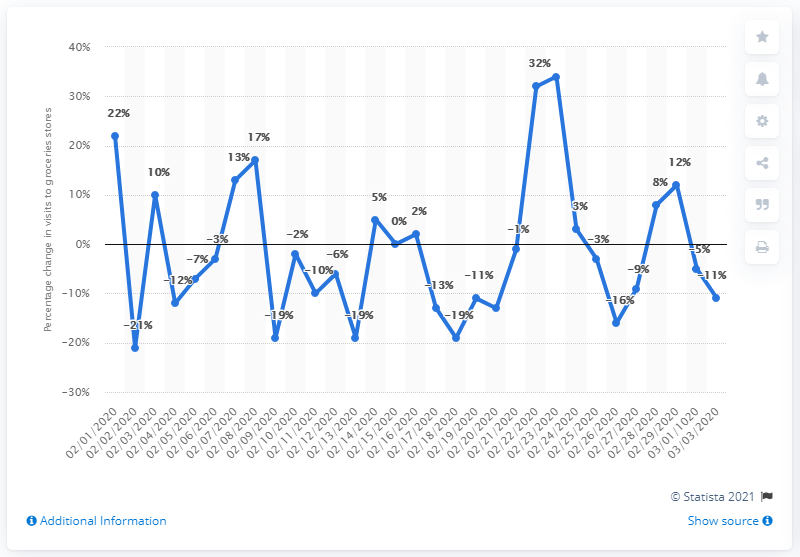Point out several critical features in this image. The number of accesses to grocery stores in Milan increased by 34% in the past year. 